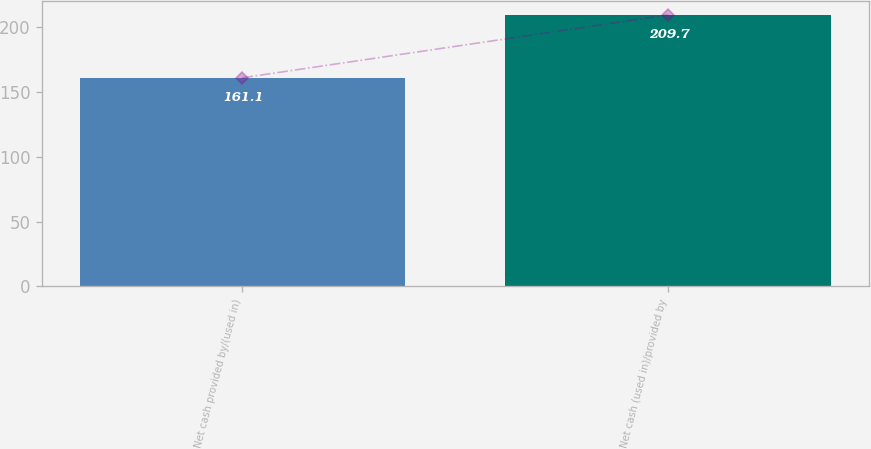<chart> <loc_0><loc_0><loc_500><loc_500><bar_chart><fcel>Net cash provided by/(used in)<fcel>Net cash (used in)/provided by<nl><fcel>161.1<fcel>209.7<nl></chart> 